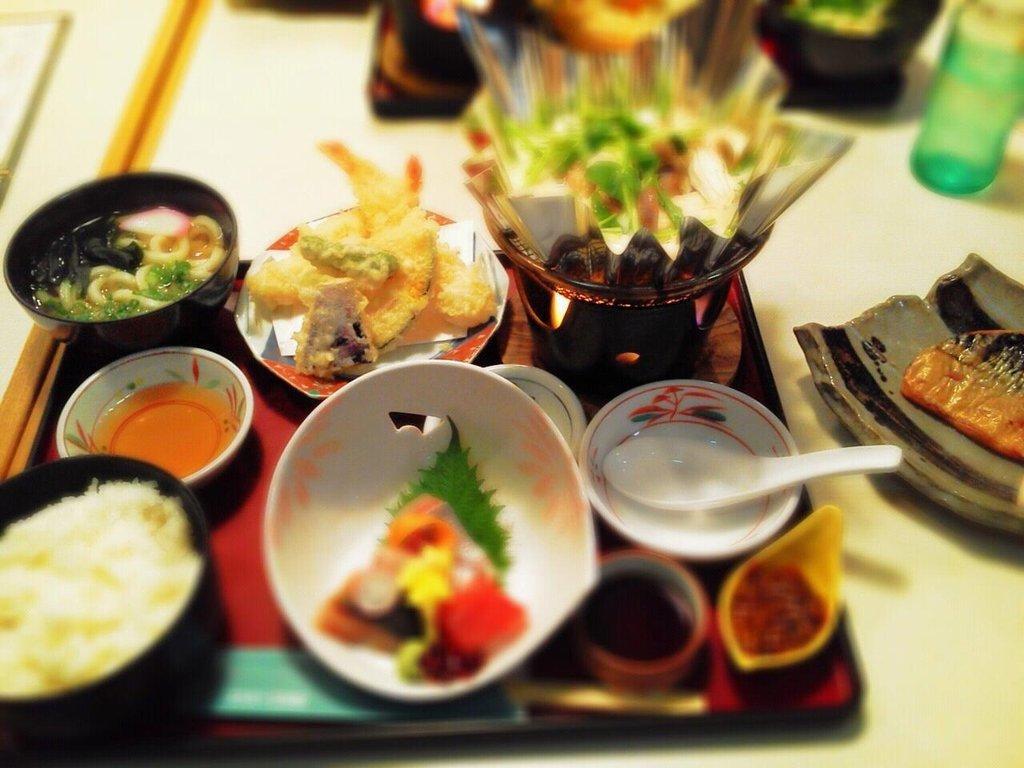In one or two sentences, can you explain what this image depicts? A plate with some food items is placed on a table. 